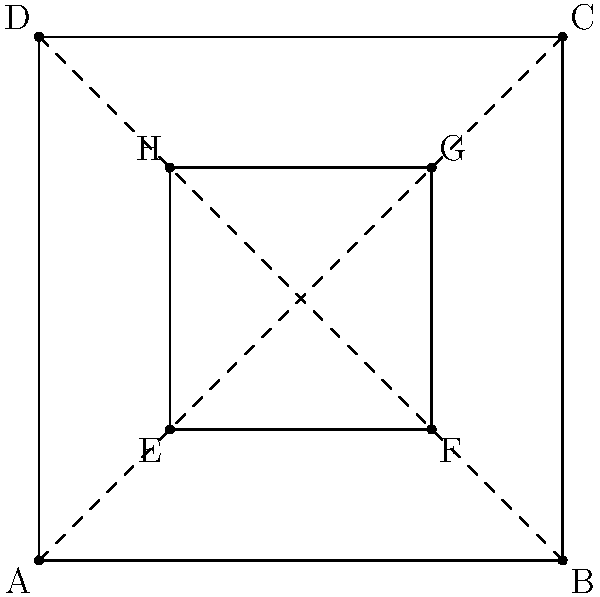Consider the floor plan of a cathedral represented by the outer square ABCD, with an inner sanctuary represented by square EFGH. If a 90-degree rotational symmetry is applied to this floor plan around the center point, how many times must this transformation be performed to return the floor plan to its original orientation? To answer this question, we need to understand rotational symmetry and its properties:

1. Rotational symmetry occurs when an object can be rotated about a fixed point and appear unchanged.

2. The order of rotational symmetry is the number of distinct orientations in which the object appears unchanged for a complete 360° rotation.

3. For a 90-degree rotation:
   - One 90° rotation = 1/4 of a full rotation
   - Two 90° rotations = 1/2 of a full rotation
   - Three 90° rotations = 3/4 of a full rotation
   - Four 90° rotations = Full rotation (back to original position)

4. The cathedral floor plan has 4-fold rotational symmetry due to its square shape:
   - It looks the same after rotations of 90°, 180°, 270°, and 360°

5. Therefore, to return to the original orientation:
   $$\frac{360°}{90°} = 4$$

Thus, the 90-degree rotation must be performed 4 times to return the floor plan to its original orientation.
Answer: 4 times 